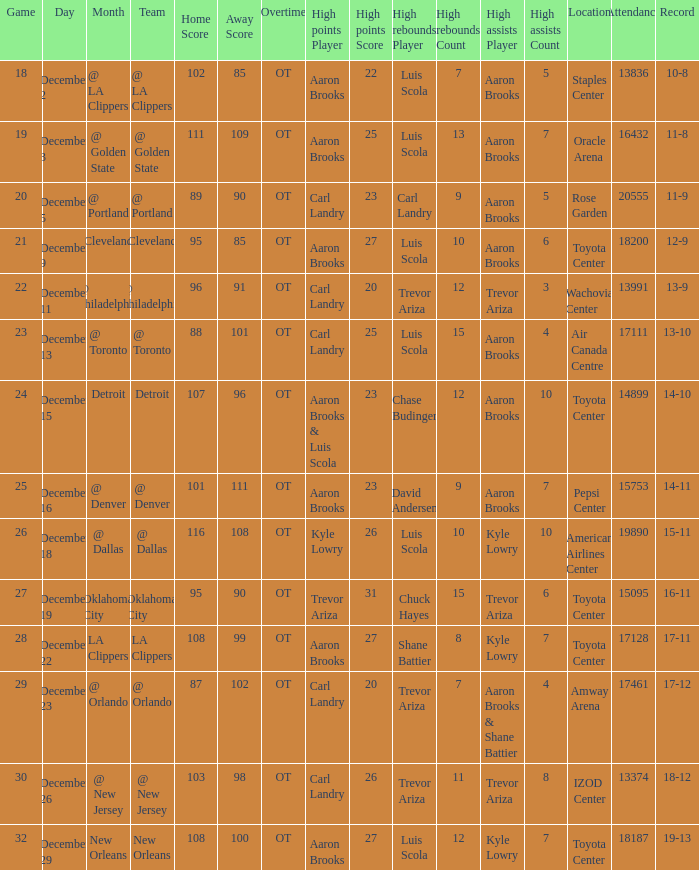Who was responsible for the highest rebounds in the game that saw carl landry (23) obtain his all-time high points? Carl Landry (9). 